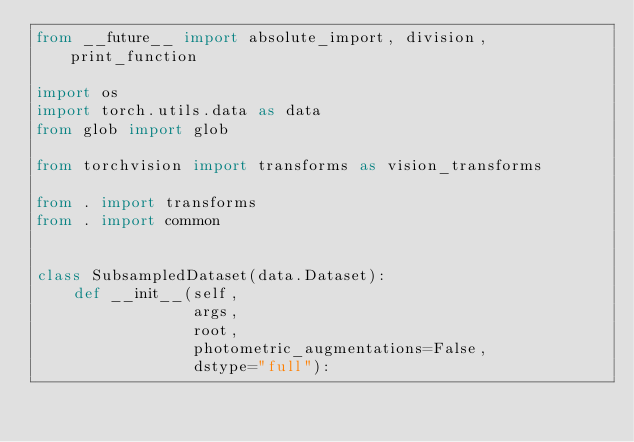<code> <loc_0><loc_0><loc_500><loc_500><_Python_>from __future__ import absolute_import, division, print_function

import os
import torch.utils.data as data
from glob import glob

from torchvision import transforms as vision_transforms

from . import transforms
from . import common


class SubsampledDataset(data.Dataset):
    def __init__(self,
                 args,
                 root,
                 photometric_augmentations=False,
                 dstype="full"):
</code> 